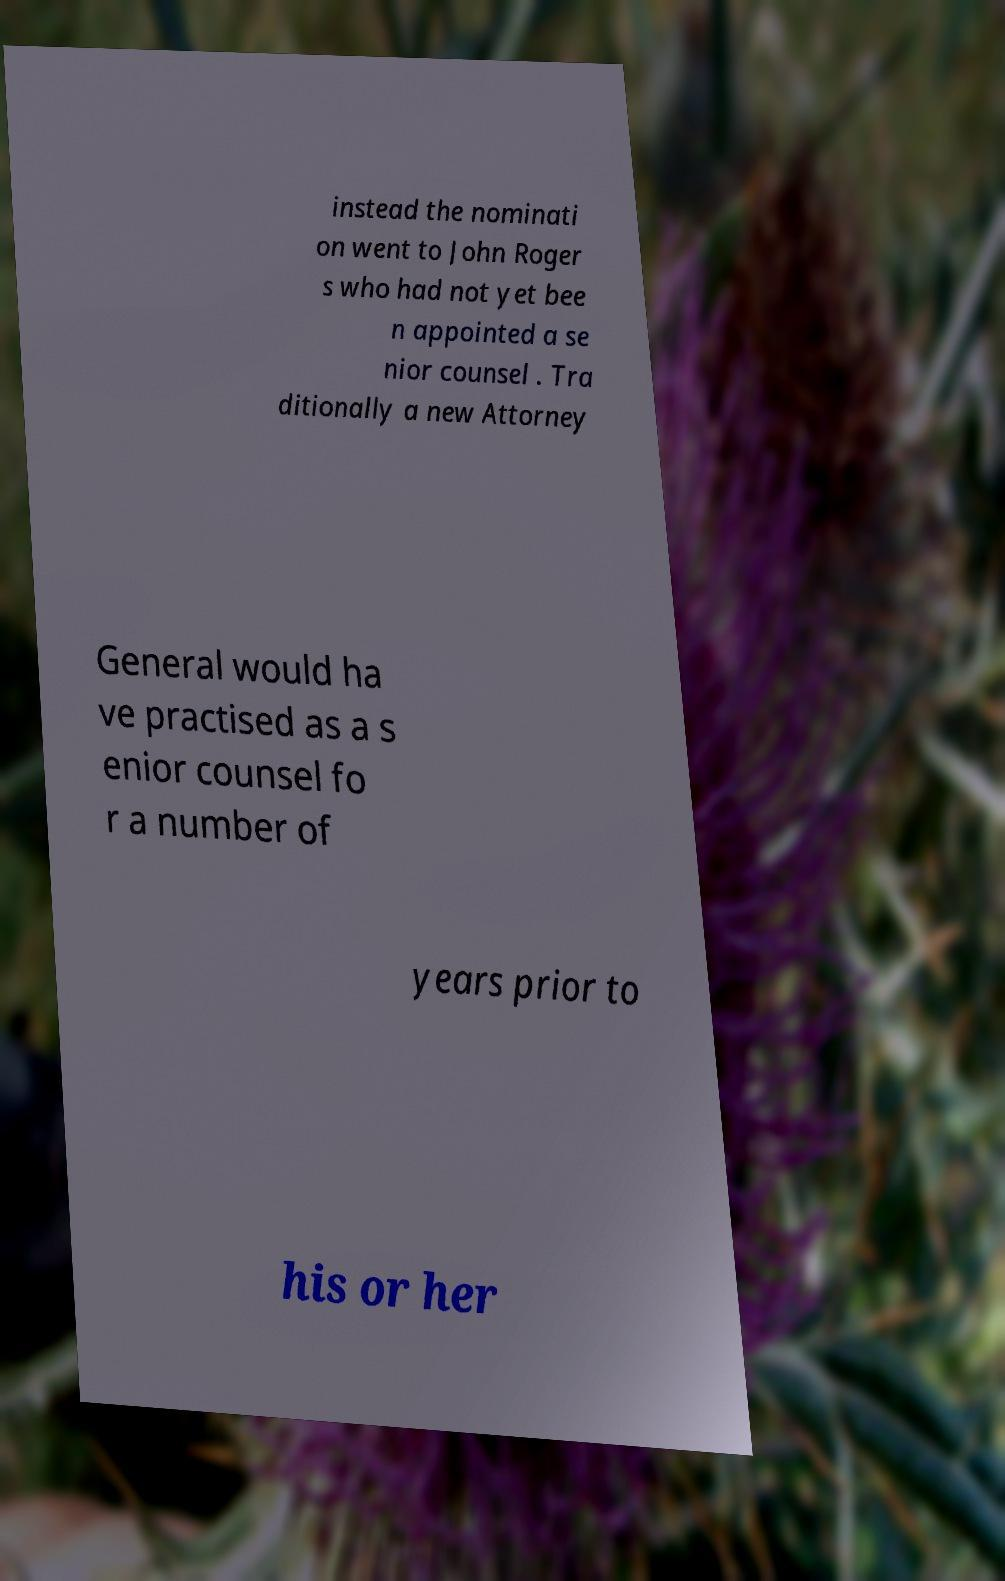For documentation purposes, I need the text within this image transcribed. Could you provide that? instead the nominati on went to John Roger s who had not yet bee n appointed a se nior counsel . Tra ditionally a new Attorney General would ha ve practised as a s enior counsel fo r a number of years prior to his or her 